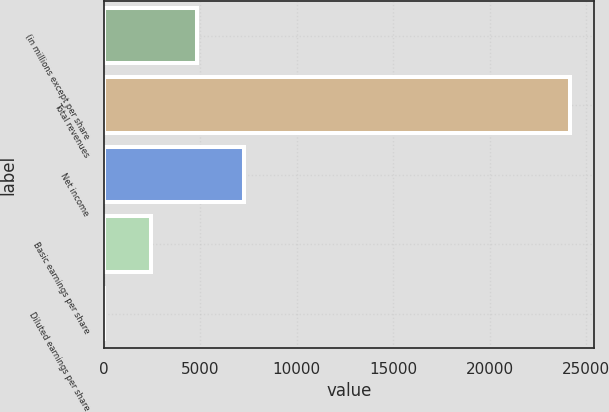<chart> <loc_0><loc_0><loc_500><loc_500><bar_chart><fcel>(in millions except per share<fcel>Total revenues<fcel>Net income<fcel>Basic earnings per share<fcel>Diluted earnings per share<nl><fcel>4837.78<fcel>24185<fcel>7256.18<fcel>2419.38<fcel>0.98<nl></chart> 